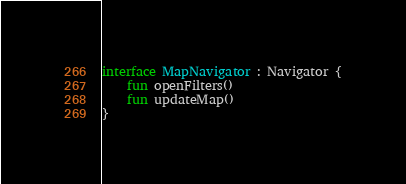Convert code to text. <code><loc_0><loc_0><loc_500><loc_500><_Kotlin_>interface MapNavigator : Navigator {
    fun openFilters()
    fun updateMap()
}</code> 